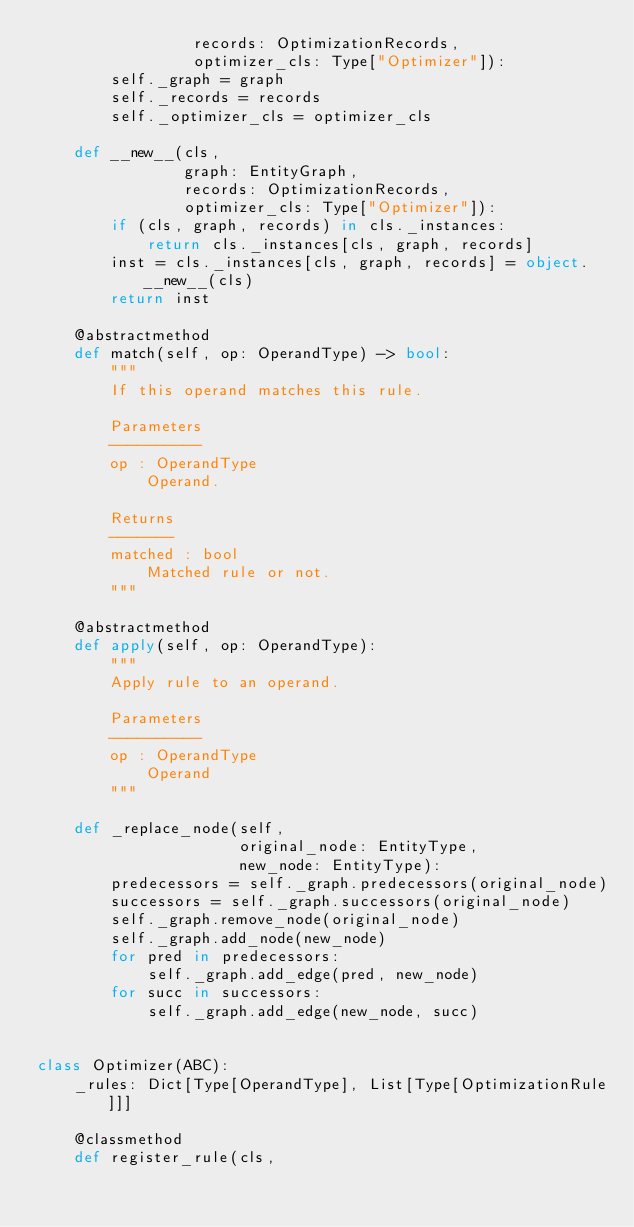<code> <loc_0><loc_0><loc_500><loc_500><_Python_>                 records: OptimizationRecords,
                 optimizer_cls: Type["Optimizer"]):
        self._graph = graph
        self._records = records
        self._optimizer_cls = optimizer_cls

    def __new__(cls,
                graph: EntityGraph,
                records: OptimizationRecords,
                optimizer_cls: Type["Optimizer"]):
        if (cls, graph, records) in cls._instances:
            return cls._instances[cls, graph, records]
        inst = cls._instances[cls, graph, records] = object.__new__(cls)
        return inst

    @abstractmethod
    def match(self, op: OperandType) -> bool:
        """
        If this operand matches this rule.

        Parameters
        ----------
        op : OperandType
            Operand.

        Returns
        -------
        matched : bool
            Matched rule or not.
        """

    @abstractmethod
    def apply(self, op: OperandType):
        """
        Apply rule to an operand.

        Parameters
        ----------
        op : OperandType
            Operand
        """

    def _replace_node(self,
                      original_node: EntityType,
                      new_node: EntityType):
        predecessors = self._graph.predecessors(original_node)
        successors = self._graph.successors(original_node)
        self._graph.remove_node(original_node)
        self._graph.add_node(new_node)
        for pred in predecessors:
            self._graph.add_edge(pred, new_node)
        for succ in successors:
            self._graph.add_edge(new_node, succ)


class Optimizer(ABC):
    _rules: Dict[Type[OperandType], List[Type[OptimizationRule]]]

    @classmethod
    def register_rule(cls,</code> 